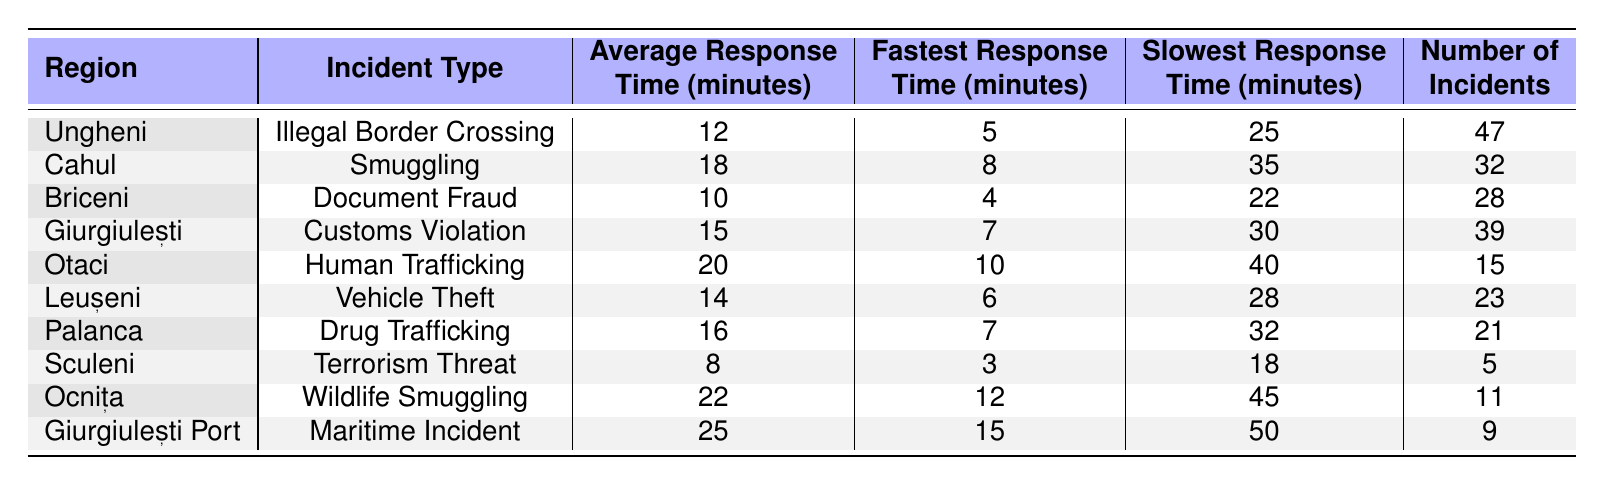What is the average response time for illegal border crossings in Ungheni? The table lists Ungheni's average response time for illegal border crossings as 12 minutes, directly available in the row corresponding to Ungheni.
Answer: 12 minutes Which region has the fastest response time for Document Fraud? The table shows that Briceni has the fastest response time for Document Fraud at 4 minutes, as indicated in the corresponding row.
Answer: 4 minutes How many incidents of human trafficking were reported in Otaci? The table states that there were 15 incidents of human trafficking in Otaci, which can be found in the relevant row of the table.
Answer: 15 incidents What is the difference between the average response time for wildlife smuggling and the average response time for drug trafficking? The average response time for wildlife smuggling in Ocnița is 22 minutes, and for drug trafficking in Palanca, it is 16 minutes. The difference is 22 - 16 = 6 minutes.
Answer: 6 minutes Is the average response time for terrorism threats in Sculeni less than 10 minutes? The average response time for terrorism threats in Sculeni is 8 minutes, which is indeed less than 10 minutes, confirming that the statement is true.
Answer: Yes Which incident type has the highest average response time? The table shows that the maritime incident at Giurgiulești Port has the highest average response time of 25 minutes, which is clearly the highest value in the 'Average Response Time' column.
Answer: 25 minutes Which region had the slowest response time for human trafficking? The table indicates that Otaci had the slowest response time for human trafficking at 40 minutes, found in the row for Otaci under the slowest response time column.
Answer: 40 minutes Calculate the average of the fastest response times across all incident types. The fastest response times listed are: 5, 8, 4, 7, 10, 6, 7, 3, 12, and 15 minutes. The sum is 73 minutes and dividing by the number of incidents (10) gives an average of 7.3 minutes.
Answer: 7.3 minutes Are there more incidents of smuggling or more incidents of vehicle theft? The table shows 32 incidents of smuggling in Cahul and 23 incidents of vehicle theft in Leușeni. Since 32 is greater than 23, there are more incidents of smuggling.
Answer: Yes In which region is the response time for customs violations greater than 15 minutes? The table shows that Giurgiulești has a response time of 15 minutes for customs violations, so there is no region with a greater response time listed; the answer is no.
Answer: No 